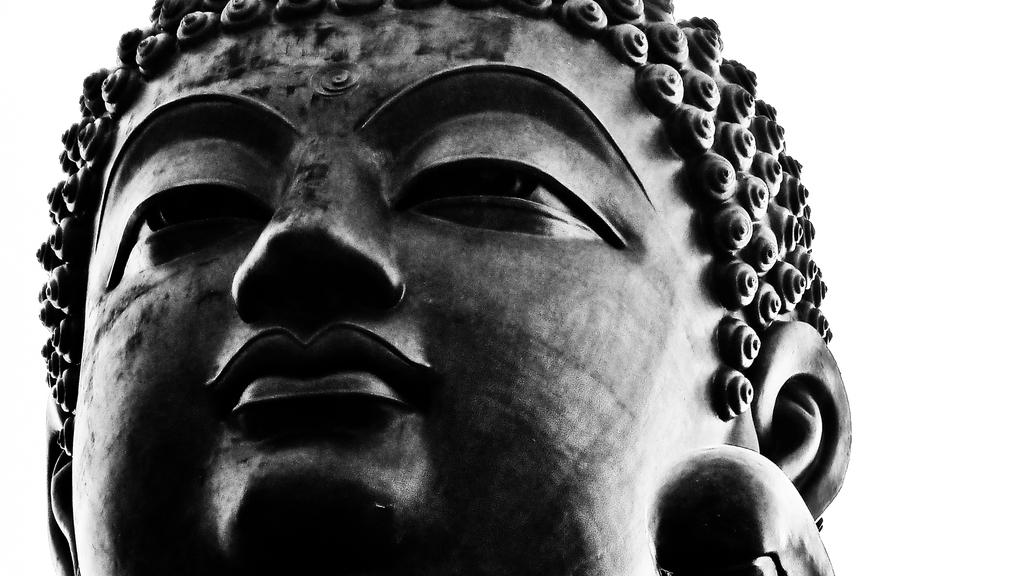What is the main subject in the image? There is a sculpture in the image. What color is the background of the image? The background of the image is white. Can you see a bag, boat, or train in the image? No, there is no bag, boat, or train visible in the image. The image only features a sculpture against a white background. 